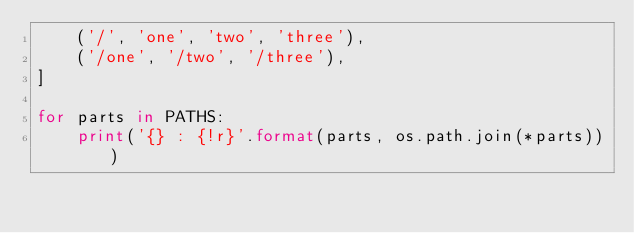Convert code to text. <code><loc_0><loc_0><loc_500><loc_500><_Python_>    ('/', 'one', 'two', 'three'),
    ('/one', '/two', '/three'),
]

for parts in PATHS:
    print('{} : {!r}'.format(parts, os.path.join(*parts)))
</code> 